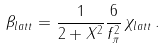Convert formula to latex. <formula><loc_0><loc_0><loc_500><loc_500>\beta _ { l a t t } = \frac { 1 } { 2 + X ^ { 2 } } \frac { 6 } { f _ { \pi } ^ { 2 } } \, \chi _ { l a t t } \, .</formula> 